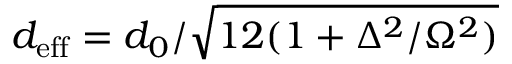<formula> <loc_0><loc_0><loc_500><loc_500>d _ { e f f } = d _ { 0 } / \sqrt { 1 2 ( 1 + \Delta ^ { 2 } / \Omega ^ { 2 } ) }</formula> 